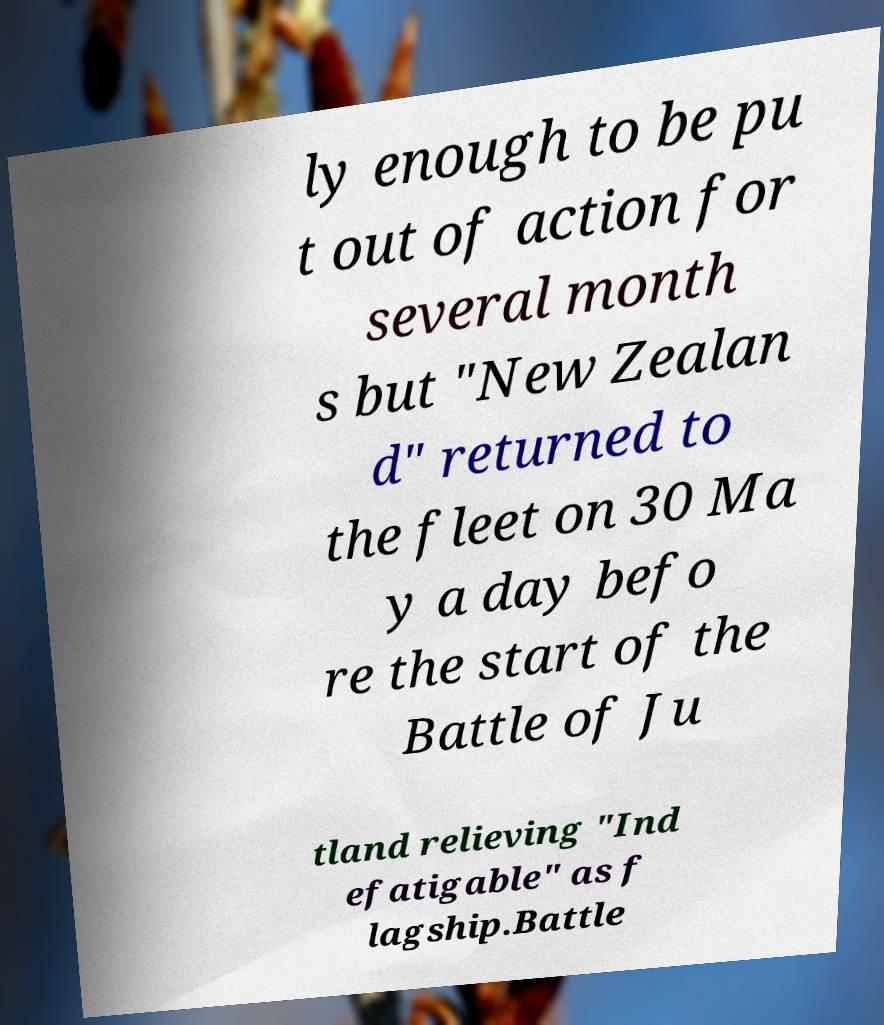Please read and relay the text visible in this image. What does it say? ly enough to be pu t out of action for several month s but "New Zealan d" returned to the fleet on 30 Ma y a day befo re the start of the Battle of Ju tland relieving "Ind efatigable" as f lagship.Battle 